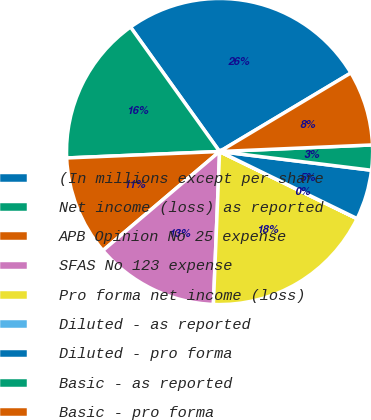<chart> <loc_0><loc_0><loc_500><loc_500><pie_chart><fcel>(In millions except per share<fcel>Net income (loss) as reported<fcel>APB Opinion No 25 expense<fcel>SFAS No 123 expense<fcel>Pro forma net income (loss)<fcel>Diluted - as reported<fcel>Diluted - pro forma<fcel>Basic - as reported<fcel>Basic - pro forma<nl><fcel>26.31%<fcel>15.79%<fcel>10.53%<fcel>13.16%<fcel>18.42%<fcel>0.01%<fcel>5.27%<fcel>2.64%<fcel>7.9%<nl></chart> 